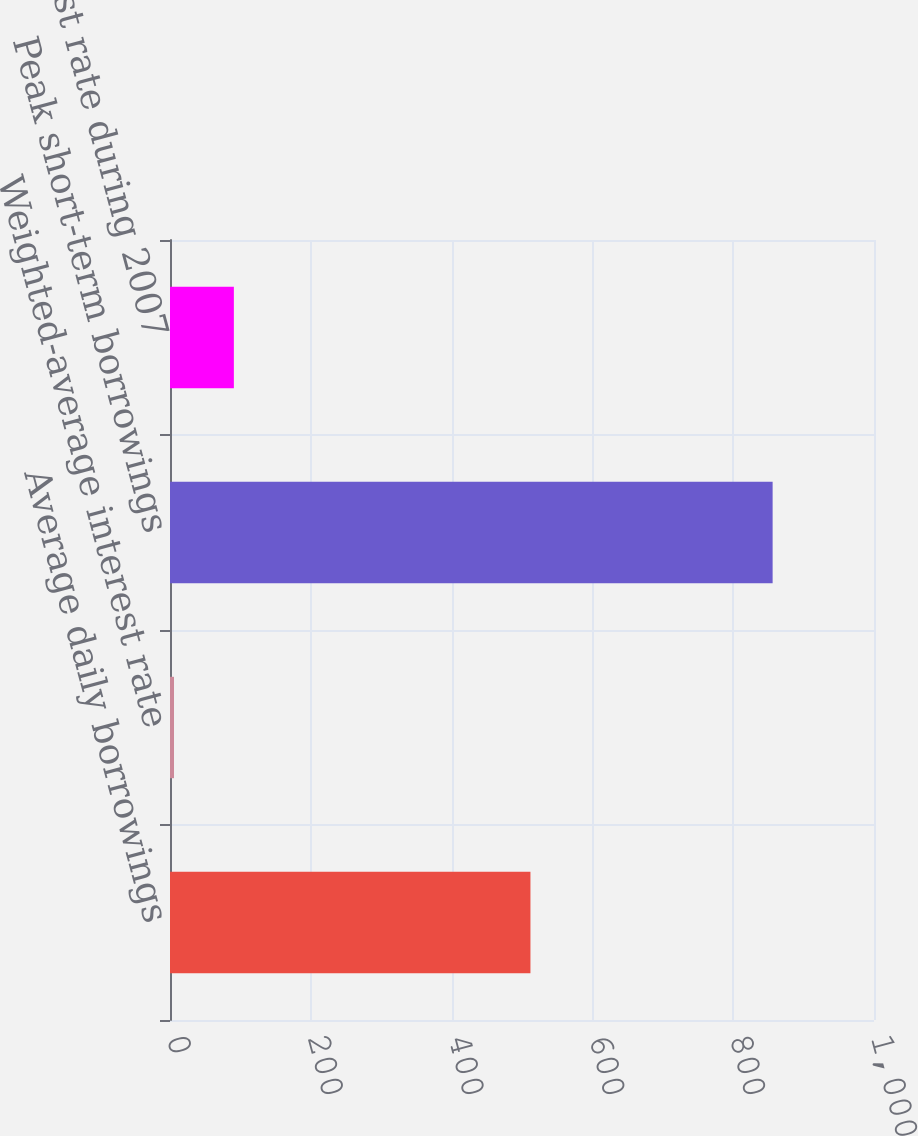<chart> <loc_0><loc_0><loc_500><loc_500><bar_chart><fcel>Average daily borrowings<fcel>Weighted-average interest rate<fcel>Peak short-term borrowings<fcel>Peak interest rate during 2007<nl><fcel>512<fcel>5.68<fcel>856<fcel>90.71<nl></chart> 